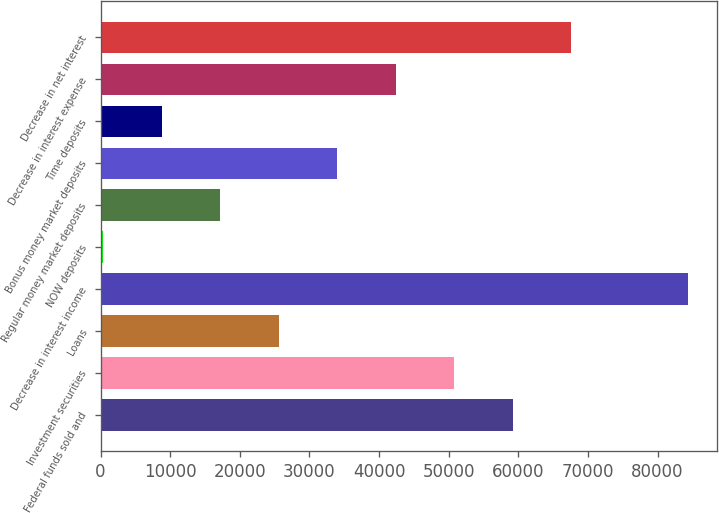Convert chart to OTSL. <chart><loc_0><loc_0><loc_500><loc_500><bar_chart><fcel>Federal funds sold and<fcel>Investment securities<fcel>Loans<fcel>Decrease in interest income<fcel>NOW deposits<fcel>Regular money market deposits<fcel>Bonus money market deposits<fcel>Time deposits<fcel>Decrease in interest expense<fcel>Decrease in net interest<nl><fcel>59172.2<fcel>50774.6<fcel>25581.8<fcel>84365<fcel>389<fcel>17184.2<fcel>33979.4<fcel>8786.6<fcel>42377<fcel>67569.8<nl></chart> 